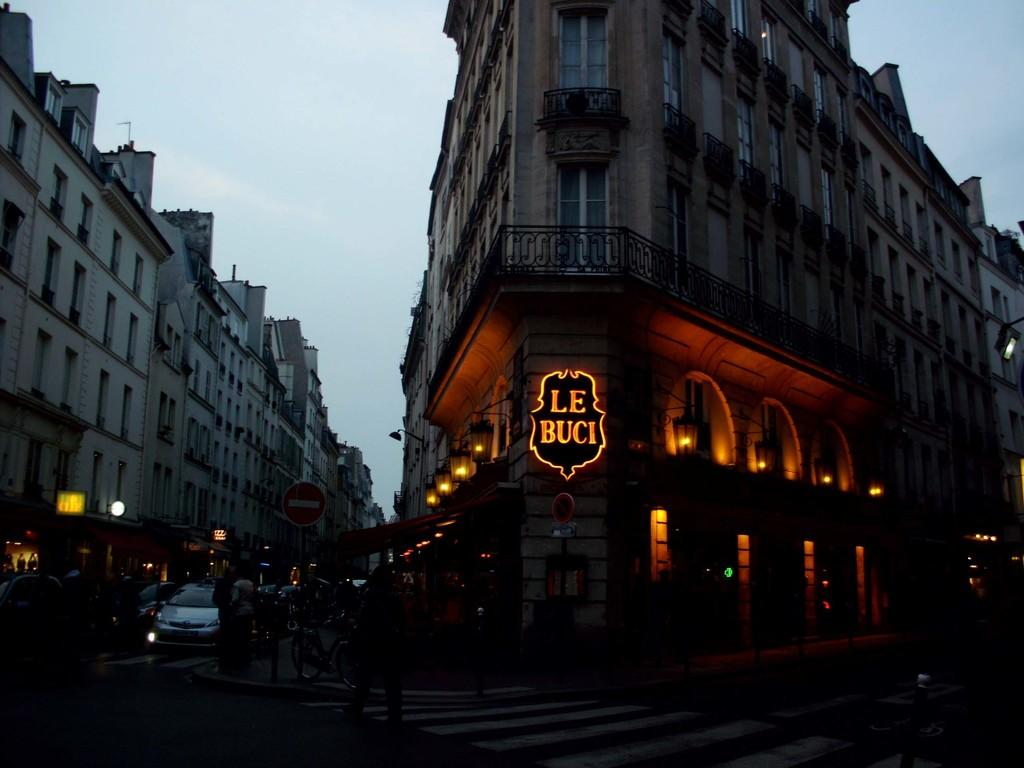How many people are in the image? There is a group of people in the image. What can be seen besides the people in the image? There are sign boards, vehicles, buildings, and lights visible in the image. Can you describe the setting of the image? The image shows a group of people in a location with sign boards, vehicles, and buildings in the background, with lights visible as well. How many eggs are being used to create the lights in the background of the image? There are no eggs present in the image, and the lights in the background are not created using eggs. 